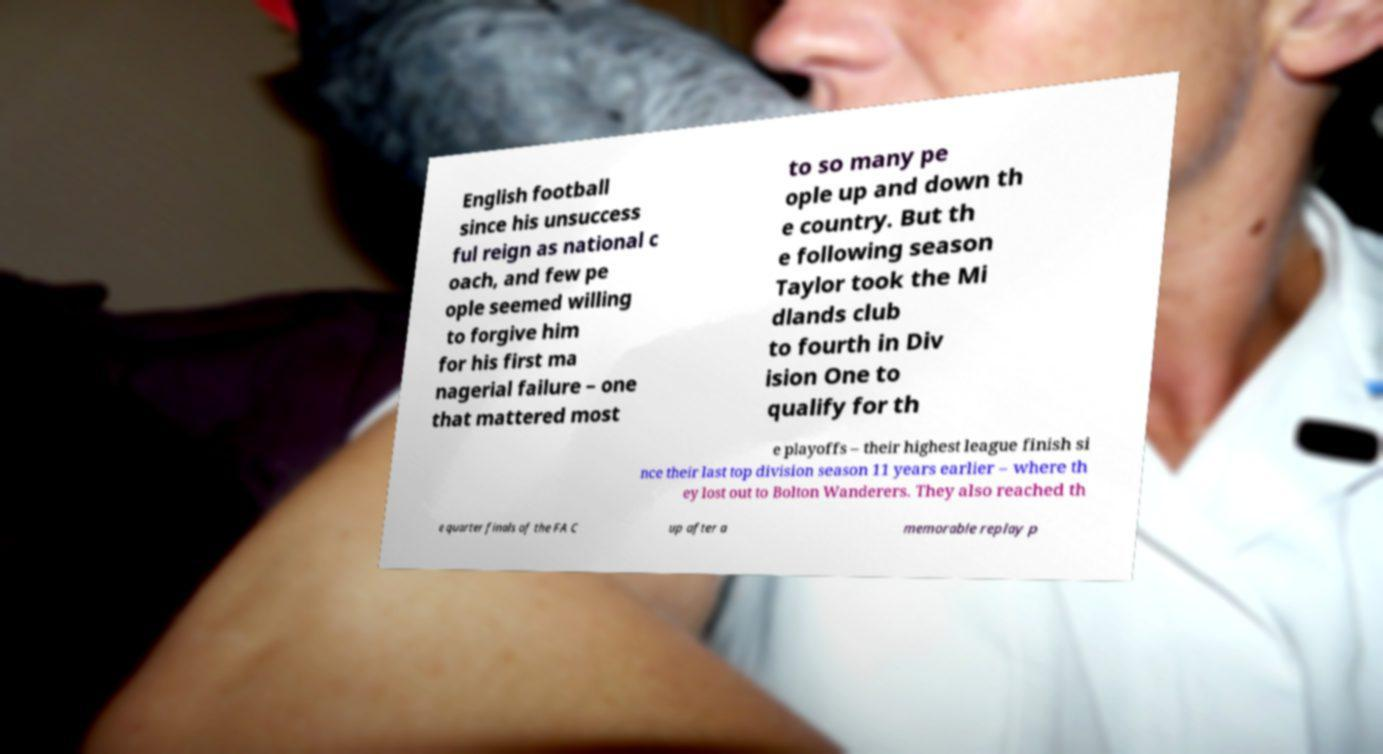There's text embedded in this image that I need extracted. Can you transcribe it verbatim? English football since his unsuccess ful reign as national c oach, and few pe ople seemed willing to forgive him for his first ma nagerial failure – one that mattered most to so many pe ople up and down th e country. But th e following season Taylor took the Mi dlands club to fourth in Div ision One to qualify for th e playoffs – their highest league finish si nce their last top division season 11 years earlier – where th ey lost out to Bolton Wanderers. They also reached th e quarter finals of the FA C up after a memorable replay p 